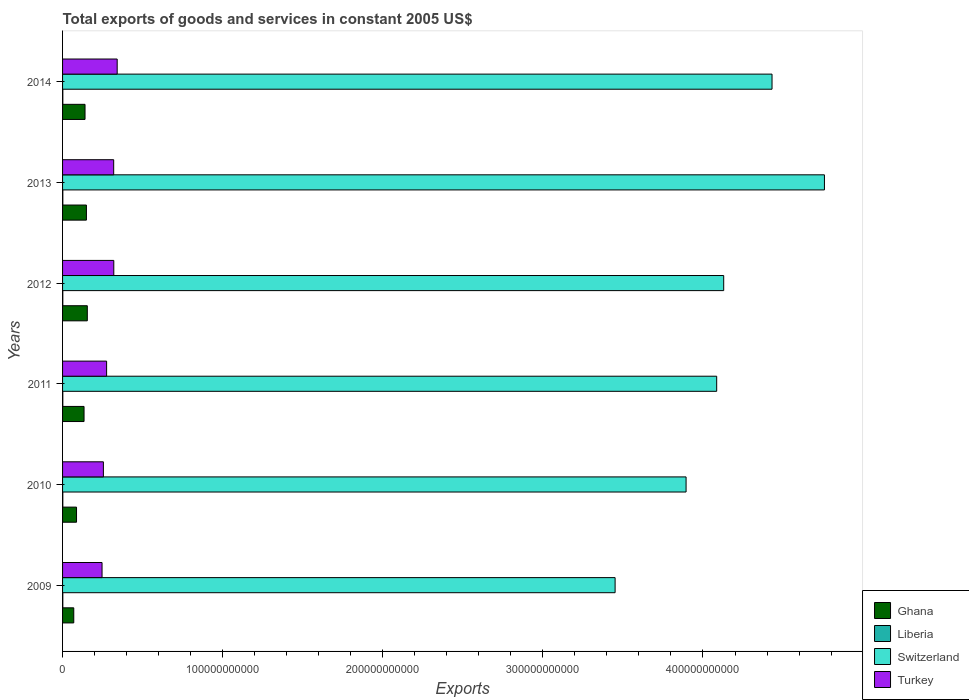How many different coloured bars are there?
Give a very brief answer. 4. Are the number of bars per tick equal to the number of legend labels?
Make the answer very short. Yes. Are the number of bars on each tick of the Y-axis equal?
Offer a very short reply. Yes. How many bars are there on the 4th tick from the top?
Your response must be concise. 4. In how many cases, is the number of bars for a given year not equal to the number of legend labels?
Make the answer very short. 0. What is the total exports of goods and services in Liberia in 2009?
Your answer should be compact. 1.51e+08. Across all years, what is the maximum total exports of goods and services in Turkey?
Make the answer very short. 3.41e+1. Across all years, what is the minimum total exports of goods and services in Ghana?
Your response must be concise. 7.00e+09. What is the total total exports of goods and services in Liberia in the graph?
Keep it short and to the point. 9.38e+08. What is the difference between the total exports of goods and services in Ghana in 2009 and that in 2014?
Your response must be concise. -7.03e+09. What is the difference between the total exports of goods and services in Liberia in 2011 and the total exports of goods and services in Switzerland in 2013?
Make the answer very short. -4.76e+11. What is the average total exports of goods and services in Switzerland per year?
Your answer should be very brief. 4.13e+11. In the year 2009, what is the difference between the total exports of goods and services in Turkey and total exports of goods and services in Ghana?
Offer a terse response. 1.77e+1. What is the ratio of the total exports of goods and services in Ghana in 2010 to that in 2012?
Offer a very short reply. 0.56. What is the difference between the highest and the second highest total exports of goods and services in Turkey?
Offer a terse response. 2.11e+09. What is the difference between the highest and the lowest total exports of goods and services in Switzerland?
Offer a terse response. 1.31e+11. Is the sum of the total exports of goods and services in Ghana in 2009 and 2010 greater than the maximum total exports of goods and services in Switzerland across all years?
Offer a very short reply. No. Is it the case that in every year, the sum of the total exports of goods and services in Switzerland and total exports of goods and services in Liberia is greater than the sum of total exports of goods and services in Turkey and total exports of goods and services in Ghana?
Offer a very short reply. Yes. Are all the bars in the graph horizontal?
Offer a terse response. Yes. What is the difference between two consecutive major ticks on the X-axis?
Your answer should be compact. 1.00e+11. Are the values on the major ticks of X-axis written in scientific E-notation?
Your answer should be very brief. No. Does the graph contain any zero values?
Ensure brevity in your answer.  No. Does the graph contain grids?
Offer a terse response. No. How many legend labels are there?
Offer a terse response. 4. What is the title of the graph?
Provide a short and direct response. Total exports of goods and services in constant 2005 US$. What is the label or title of the X-axis?
Make the answer very short. Exports. What is the label or title of the Y-axis?
Provide a short and direct response. Years. What is the Exports in Ghana in 2009?
Ensure brevity in your answer.  7.00e+09. What is the Exports in Liberia in 2009?
Ensure brevity in your answer.  1.51e+08. What is the Exports in Switzerland in 2009?
Offer a terse response. 3.45e+11. What is the Exports of Turkey in 2009?
Keep it short and to the point. 2.47e+1. What is the Exports in Ghana in 2010?
Offer a very short reply. 8.72e+09. What is the Exports in Liberia in 2010?
Ensure brevity in your answer.  1.53e+08. What is the Exports in Switzerland in 2010?
Offer a very short reply. 3.89e+11. What is the Exports of Turkey in 2010?
Provide a short and direct response. 2.55e+1. What is the Exports of Ghana in 2011?
Your response must be concise. 1.34e+1. What is the Exports of Liberia in 2011?
Give a very brief answer. 1.55e+08. What is the Exports of Switzerland in 2011?
Keep it short and to the point. 4.09e+11. What is the Exports in Turkey in 2011?
Ensure brevity in your answer.  2.75e+1. What is the Exports in Ghana in 2012?
Ensure brevity in your answer.  1.55e+1. What is the Exports of Liberia in 2012?
Your answer should be compact. 1.57e+08. What is the Exports in Switzerland in 2012?
Offer a very short reply. 4.13e+11. What is the Exports of Turkey in 2012?
Provide a short and direct response. 3.20e+1. What is the Exports of Ghana in 2013?
Your answer should be compact. 1.49e+1. What is the Exports of Liberia in 2013?
Make the answer very short. 1.60e+08. What is the Exports in Switzerland in 2013?
Offer a very short reply. 4.76e+11. What is the Exports of Turkey in 2013?
Your response must be concise. 3.19e+1. What is the Exports of Ghana in 2014?
Keep it short and to the point. 1.40e+1. What is the Exports of Liberia in 2014?
Ensure brevity in your answer.  1.62e+08. What is the Exports in Switzerland in 2014?
Your answer should be very brief. 4.43e+11. What is the Exports of Turkey in 2014?
Provide a short and direct response. 3.41e+1. Across all years, what is the maximum Exports of Ghana?
Your response must be concise. 1.55e+1. Across all years, what is the maximum Exports of Liberia?
Offer a terse response. 1.62e+08. Across all years, what is the maximum Exports in Switzerland?
Your answer should be compact. 4.76e+11. Across all years, what is the maximum Exports in Turkey?
Provide a succinct answer. 3.41e+1. Across all years, what is the minimum Exports of Ghana?
Provide a short and direct response. 7.00e+09. Across all years, what is the minimum Exports in Liberia?
Your answer should be very brief. 1.51e+08. Across all years, what is the minimum Exports in Switzerland?
Offer a terse response. 3.45e+11. Across all years, what is the minimum Exports of Turkey?
Provide a succinct answer. 2.47e+1. What is the total Exports of Ghana in the graph?
Your answer should be compact. 7.35e+1. What is the total Exports of Liberia in the graph?
Offer a terse response. 9.38e+08. What is the total Exports in Switzerland in the graph?
Ensure brevity in your answer.  2.48e+12. What is the total Exports of Turkey in the graph?
Offer a terse response. 1.76e+11. What is the difference between the Exports of Ghana in 2009 and that in 2010?
Give a very brief answer. -1.73e+09. What is the difference between the Exports in Liberia in 2009 and that in 2010?
Provide a short and direct response. -2.00e+06. What is the difference between the Exports in Switzerland in 2009 and that in 2010?
Ensure brevity in your answer.  -4.43e+1. What is the difference between the Exports of Turkey in 2009 and that in 2010?
Keep it short and to the point. -8.40e+08. What is the difference between the Exports of Ghana in 2009 and that in 2011?
Give a very brief answer. -6.42e+09. What is the difference between the Exports in Liberia in 2009 and that in 2011?
Your response must be concise. -4.09e+06. What is the difference between the Exports of Switzerland in 2009 and that in 2011?
Your response must be concise. -6.34e+1. What is the difference between the Exports of Turkey in 2009 and that in 2011?
Ensure brevity in your answer.  -2.85e+09. What is the difference between the Exports of Ghana in 2009 and that in 2012?
Offer a very short reply. -8.46e+09. What is the difference between the Exports of Liberia in 2009 and that in 2012?
Offer a very short reply. -6.21e+06. What is the difference between the Exports in Switzerland in 2009 and that in 2012?
Offer a terse response. -6.78e+1. What is the difference between the Exports in Turkey in 2009 and that in 2012?
Make the answer very short. -7.34e+09. What is the difference between the Exports of Ghana in 2009 and that in 2013?
Give a very brief answer. -7.90e+09. What is the difference between the Exports of Liberia in 2009 and that in 2013?
Your answer should be compact. -8.36e+06. What is the difference between the Exports of Switzerland in 2009 and that in 2013?
Your answer should be compact. -1.31e+11. What is the difference between the Exports in Turkey in 2009 and that in 2013?
Keep it short and to the point. -7.27e+09. What is the difference between the Exports in Ghana in 2009 and that in 2014?
Your response must be concise. -7.03e+09. What is the difference between the Exports of Liberia in 2009 and that in 2014?
Provide a succinct answer. -1.05e+07. What is the difference between the Exports in Switzerland in 2009 and that in 2014?
Your answer should be compact. -9.80e+1. What is the difference between the Exports in Turkey in 2009 and that in 2014?
Ensure brevity in your answer.  -9.45e+09. What is the difference between the Exports of Ghana in 2010 and that in 2011?
Make the answer very short. -4.70e+09. What is the difference between the Exports in Liberia in 2010 and that in 2011?
Provide a short and direct response. -2.09e+06. What is the difference between the Exports of Switzerland in 2010 and that in 2011?
Your answer should be very brief. -1.91e+1. What is the difference between the Exports in Turkey in 2010 and that in 2011?
Your answer should be compact. -2.01e+09. What is the difference between the Exports of Ghana in 2010 and that in 2012?
Your answer should be very brief. -6.73e+09. What is the difference between the Exports in Liberia in 2010 and that in 2012?
Ensure brevity in your answer.  -4.21e+06. What is the difference between the Exports in Switzerland in 2010 and that in 2012?
Offer a very short reply. -2.35e+1. What is the difference between the Exports in Turkey in 2010 and that in 2012?
Your answer should be very brief. -6.50e+09. What is the difference between the Exports of Ghana in 2010 and that in 2013?
Offer a terse response. -6.18e+09. What is the difference between the Exports in Liberia in 2010 and that in 2013?
Offer a terse response. -6.36e+06. What is the difference between the Exports in Switzerland in 2010 and that in 2013?
Ensure brevity in your answer.  -8.64e+1. What is the difference between the Exports of Turkey in 2010 and that in 2013?
Give a very brief answer. -6.43e+09. What is the difference between the Exports of Ghana in 2010 and that in 2014?
Your answer should be very brief. -5.31e+09. What is the difference between the Exports in Liberia in 2010 and that in 2014?
Make the answer very short. -8.54e+06. What is the difference between the Exports of Switzerland in 2010 and that in 2014?
Give a very brief answer. -5.37e+1. What is the difference between the Exports in Turkey in 2010 and that in 2014?
Offer a very short reply. -8.61e+09. What is the difference between the Exports of Ghana in 2011 and that in 2012?
Offer a very short reply. -2.04e+09. What is the difference between the Exports of Liberia in 2011 and that in 2012?
Provide a short and direct response. -2.12e+06. What is the difference between the Exports in Switzerland in 2011 and that in 2012?
Your answer should be very brief. -4.38e+09. What is the difference between the Exports in Turkey in 2011 and that in 2012?
Your response must be concise. -4.49e+09. What is the difference between the Exports in Ghana in 2011 and that in 2013?
Make the answer very short. -1.48e+09. What is the difference between the Exports of Liberia in 2011 and that in 2013?
Make the answer very short. -4.27e+06. What is the difference between the Exports of Switzerland in 2011 and that in 2013?
Provide a succinct answer. -6.73e+1. What is the difference between the Exports in Turkey in 2011 and that in 2013?
Offer a terse response. -4.42e+09. What is the difference between the Exports of Ghana in 2011 and that in 2014?
Your answer should be compact. -6.12e+08. What is the difference between the Exports in Liberia in 2011 and that in 2014?
Keep it short and to the point. -6.45e+06. What is the difference between the Exports of Switzerland in 2011 and that in 2014?
Offer a very short reply. -3.46e+1. What is the difference between the Exports in Turkey in 2011 and that in 2014?
Ensure brevity in your answer.  -6.60e+09. What is the difference between the Exports in Ghana in 2012 and that in 2013?
Provide a short and direct response. 5.57e+08. What is the difference between the Exports of Liberia in 2012 and that in 2013?
Your answer should be very brief. -2.15e+06. What is the difference between the Exports in Switzerland in 2012 and that in 2013?
Your response must be concise. -6.29e+1. What is the difference between the Exports in Turkey in 2012 and that in 2013?
Give a very brief answer. 6.73e+07. What is the difference between the Exports of Ghana in 2012 and that in 2014?
Make the answer very short. 1.43e+09. What is the difference between the Exports in Liberia in 2012 and that in 2014?
Give a very brief answer. -4.33e+06. What is the difference between the Exports in Switzerland in 2012 and that in 2014?
Provide a succinct answer. -3.02e+1. What is the difference between the Exports in Turkey in 2012 and that in 2014?
Offer a terse response. -2.11e+09. What is the difference between the Exports in Ghana in 2013 and that in 2014?
Give a very brief answer. 8.69e+08. What is the difference between the Exports of Liberia in 2013 and that in 2014?
Keep it short and to the point. -2.18e+06. What is the difference between the Exports of Switzerland in 2013 and that in 2014?
Provide a short and direct response. 3.27e+1. What is the difference between the Exports in Turkey in 2013 and that in 2014?
Your response must be concise. -2.18e+09. What is the difference between the Exports in Ghana in 2009 and the Exports in Liberia in 2010?
Provide a short and direct response. 6.84e+09. What is the difference between the Exports of Ghana in 2009 and the Exports of Switzerland in 2010?
Offer a terse response. -3.82e+11. What is the difference between the Exports in Ghana in 2009 and the Exports in Turkey in 2010?
Your response must be concise. -1.85e+1. What is the difference between the Exports in Liberia in 2009 and the Exports in Switzerland in 2010?
Give a very brief answer. -3.89e+11. What is the difference between the Exports in Liberia in 2009 and the Exports in Turkey in 2010?
Your answer should be very brief. -2.53e+1. What is the difference between the Exports of Switzerland in 2009 and the Exports of Turkey in 2010?
Keep it short and to the point. 3.20e+11. What is the difference between the Exports in Ghana in 2009 and the Exports in Liberia in 2011?
Provide a succinct answer. 6.84e+09. What is the difference between the Exports in Ghana in 2009 and the Exports in Switzerland in 2011?
Provide a short and direct response. -4.02e+11. What is the difference between the Exports of Ghana in 2009 and the Exports of Turkey in 2011?
Your response must be concise. -2.05e+1. What is the difference between the Exports of Liberia in 2009 and the Exports of Switzerland in 2011?
Your response must be concise. -4.08e+11. What is the difference between the Exports in Liberia in 2009 and the Exports in Turkey in 2011?
Your answer should be compact. -2.74e+1. What is the difference between the Exports of Switzerland in 2009 and the Exports of Turkey in 2011?
Provide a short and direct response. 3.18e+11. What is the difference between the Exports in Ghana in 2009 and the Exports in Liberia in 2012?
Your answer should be compact. 6.84e+09. What is the difference between the Exports in Ghana in 2009 and the Exports in Switzerland in 2012?
Keep it short and to the point. -4.06e+11. What is the difference between the Exports of Ghana in 2009 and the Exports of Turkey in 2012?
Give a very brief answer. -2.50e+1. What is the difference between the Exports in Liberia in 2009 and the Exports in Switzerland in 2012?
Your answer should be very brief. -4.13e+11. What is the difference between the Exports of Liberia in 2009 and the Exports of Turkey in 2012?
Keep it short and to the point. -3.18e+1. What is the difference between the Exports of Switzerland in 2009 and the Exports of Turkey in 2012?
Offer a terse response. 3.13e+11. What is the difference between the Exports in Ghana in 2009 and the Exports in Liberia in 2013?
Keep it short and to the point. 6.84e+09. What is the difference between the Exports of Ghana in 2009 and the Exports of Switzerland in 2013?
Keep it short and to the point. -4.69e+11. What is the difference between the Exports of Ghana in 2009 and the Exports of Turkey in 2013?
Offer a very short reply. -2.49e+1. What is the difference between the Exports in Liberia in 2009 and the Exports in Switzerland in 2013?
Your response must be concise. -4.76e+11. What is the difference between the Exports of Liberia in 2009 and the Exports of Turkey in 2013?
Your response must be concise. -3.18e+1. What is the difference between the Exports of Switzerland in 2009 and the Exports of Turkey in 2013?
Offer a very short reply. 3.13e+11. What is the difference between the Exports in Ghana in 2009 and the Exports in Liberia in 2014?
Ensure brevity in your answer.  6.83e+09. What is the difference between the Exports in Ghana in 2009 and the Exports in Switzerland in 2014?
Make the answer very short. -4.36e+11. What is the difference between the Exports in Ghana in 2009 and the Exports in Turkey in 2014?
Give a very brief answer. -2.71e+1. What is the difference between the Exports in Liberia in 2009 and the Exports in Switzerland in 2014?
Offer a very short reply. -4.43e+11. What is the difference between the Exports in Liberia in 2009 and the Exports in Turkey in 2014?
Offer a very short reply. -3.40e+1. What is the difference between the Exports in Switzerland in 2009 and the Exports in Turkey in 2014?
Offer a terse response. 3.11e+11. What is the difference between the Exports of Ghana in 2010 and the Exports of Liberia in 2011?
Keep it short and to the point. 8.57e+09. What is the difference between the Exports of Ghana in 2010 and the Exports of Switzerland in 2011?
Provide a short and direct response. -4.00e+11. What is the difference between the Exports of Ghana in 2010 and the Exports of Turkey in 2011?
Keep it short and to the point. -1.88e+1. What is the difference between the Exports of Liberia in 2010 and the Exports of Switzerland in 2011?
Your answer should be compact. -4.08e+11. What is the difference between the Exports in Liberia in 2010 and the Exports in Turkey in 2011?
Keep it short and to the point. -2.74e+1. What is the difference between the Exports of Switzerland in 2010 and the Exports of Turkey in 2011?
Keep it short and to the point. 3.62e+11. What is the difference between the Exports of Ghana in 2010 and the Exports of Liberia in 2012?
Provide a succinct answer. 8.57e+09. What is the difference between the Exports of Ghana in 2010 and the Exports of Switzerland in 2012?
Provide a short and direct response. -4.04e+11. What is the difference between the Exports in Ghana in 2010 and the Exports in Turkey in 2012?
Make the answer very short. -2.33e+1. What is the difference between the Exports in Liberia in 2010 and the Exports in Switzerland in 2012?
Your answer should be very brief. -4.13e+11. What is the difference between the Exports in Liberia in 2010 and the Exports in Turkey in 2012?
Your response must be concise. -3.18e+1. What is the difference between the Exports of Switzerland in 2010 and the Exports of Turkey in 2012?
Give a very brief answer. 3.57e+11. What is the difference between the Exports in Ghana in 2010 and the Exports in Liberia in 2013?
Give a very brief answer. 8.56e+09. What is the difference between the Exports of Ghana in 2010 and the Exports of Switzerland in 2013?
Offer a very short reply. -4.67e+11. What is the difference between the Exports of Ghana in 2010 and the Exports of Turkey in 2013?
Provide a succinct answer. -2.32e+1. What is the difference between the Exports in Liberia in 2010 and the Exports in Switzerland in 2013?
Your response must be concise. -4.76e+11. What is the difference between the Exports of Liberia in 2010 and the Exports of Turkey in 2013?
Offer a terse response. -3.18e+1. What is the difference between the Exports of Switzerland in 2010 and the Exports of Turkey in 2013?
Provide a short and direct response. 3.58e+11. What is the difference between the Exports of Ghana in 2010 and the Exports of Liberia in 2014?
Offer a terse response. 8.56e+09. What is the difference between the Exports in Ghana in 2010 and the Exports in Switzerland in 2014?
Your answer should be compact. -4.34e+11. What is the difference between the Exports in Ghana in 2010 and the Exports in Turkey in 2014?
Your response must be concise. -2.54e+1. What is the difference between the Exports in Liberia in 2010 and the Exports in Switzerland in 2014?
Make the answer very short. -4.43e+11. What is the difference between the Exports in Liberia in 2010 and the Exports in Turkey in 2014?
Keep it short and to the point. -3.40e+1. What is the difference between the Exports in Switzerland in 2010 and the Exports in Turkey in 2014?
Your response must be concise. 3.55e+11. What is the difference between the Exports in Ghana in 2011 and the Exports in Liberia in 2012?
Make the answer very short. 1.33e+1. What is the difference between the Exports in Ghana in 2011 and the Exports in Switzerland in 2012?
Provide a succinct answer. -4.00e+11. What is the difference between the Exports in Ghana in 2011 and the Exports in Turkey in 2012?
Offer a terse response. -1.86e+1. What is the difference between the Exports of Liberia in 2011 and the Exports of Switzerland in 2012?
Keep it short and to the point. -4.13e+11. What is the difference between the Exports in Liberia in 2011 and the Exports in Turkey in 2012?
Your answer should be very brief. -3.18e+1. What is the difference between the Exports in Switzerland in 2011 and the Exports in Turkey in 2012?
Your response must be concise. 3.77e+11. What is the difference between the Exports of Ghana in 2011 and the Exports of Liberia in 2013?
Your answer should be compact. 1.33e+1. What is the difference between the Exports in Ghana in 2011 and the Exports in Switzerland in 2013?
Your answer should be compact. -4.62e+11. What is the difference between the Exports of Ghana in 2011 and the Exports of Turkey in 2013?
Your answer should be very brief. -1.85e+1. What is the difference between the Exports in Liberia in 2011 and the Exports in Switzerland in 2013?
Provide a short and direct response. -4.76e+11. What is the difference between the Exports in Liberia in 2011 and the Exports in Turkey in 2013?
Keep it short and to the point. -3.18e+1. What is the difference between the Exports in Switzerland in 2011 and the Exports in Turkey in 2013?
Provide a succinct answer. 3.77e+11. What is the difference between the Exports of Ghana in 2011 and the Exports of Liberia in 2014?
Ensure brevity in your answer.  1.33e+1. What is the difference between the Exports in Ghana in 2011 and the Exports in Switzerland in 2014?
Provide a short and direct response. -4.30e+11. What is the difference between the Exports in Ghana in 2011 and the Exports in Turkey in 2014?
Your answer should be compact. -2.07e+1. What is the difference between the Exports of Liberia in 2011 and the Exports of Switzerland in 2014?
Provide a short and direct response. -4.43e+11. What is the difference between the Exports in Liberia in 2011 and the Exports in Turkey in 2014?
Offer a terse response. -3.40e+1. What is the difference between the Exports of Switzerland in 2011 and the Exports of Turkey in 2014?
Your response must be concise. 3.74e+11. What is the difference between the Exports of Ghana in 2012 and the Exports of Liberia in 2013?
Your answer should be very brief. 1.53e+1. What is the difference between the Exports in Ghana in 2012 and the Exports in Switzerland in 2013?
Ensure brevity in your answer.  -4.60e+11. What is the difference between the Exports in Ghana in 2012 and the Exports in Turkey in 2013?
Make the answer very short. -1.65e+1. What is the difference between the Exports of Liberia in 2012 and the Exports of Switzerland in 2013?
Your answer should be compact. -4.76e+11. What is the difference between the Exports in Liberia in 2012 and the Exports in Turkey in 2013?
Give a very brief answer. -3.18e+1. What is the difference between the Exports in Switzerland in 2012 and the Exports in Turkey in 2013?
Ensure brevity in your answer.  3.81e+11. What is the difference between the Exports of Ghana in 2012 and the Exports of Liberia in 2014?
Give a very brief answer. 1.53e+1. What is the difference between the Exports in Ghana in 2012 and the Exports in Switzerland in 2014?
Keep it short and to the point. -4.28e+11. What is the difference between the Exports of Ghana in 2012 and the Exports of Turkey in 2014?
Keep it short and to the point. -1.87e+1. What is the difference between the Exports of Liberia in 2012 and the Exports of Switzerland in 2014?
Provide a short and direct response. -4.43e+11. What is the difference between the Exports in Liberia in 2012 and the Exports in Turkey in 2014?
Your response must be concise. -3.40e+1. What is the difference between the Exports in Switzerland in 2012 and the Exports in Turkey in 2014?
Make the answer very short. 3.79e+11. What is the difference between the Exports in Ghana in 2013 and the Exports in Liberia in 2014?
Your answer should be compact. 1.47e+1. What is the difference between the Exports of Ghana in 2013 and the Exports of Switzerland in 2014?
Your response must be concise. -4.28e+11. What is the difference between the Exports in Ghana in 2013 and the Exports in Turkey in 2014?
Offer a very short reply. -1.92e+1. What is the difference between the Exports in Liberia in 2013 and the Exports in Switzerland in 2014?
Provide a short and direct response. -4.43e+11. What is the difference between the Exports of Liberia in 2013 and the Exports of Turkey in 2014?
Ensure brevity in your answer.  -3.40e+1. What is the difference between the Exports in Switzerland in 2013 and the Exports in Turkey in 2014?
Provide a succinct answer. 4.42e+11. What is the average Exports of Ghana per year?
Your response must be concise. 1.23e+1. What is the average Exports of Liberia per year?
Provide a short and direct response. 1.56e+08. What is the average Exports in Switzerland per year?
Your answer should be compact. 4.13e+11. What is the average Exports of Turkey per year?
Provide a succinct answer. 2.93e+1. In the year 2009, what is the difference between the Exports in Ghana and Exports in Liberia?
Offer a very short reply. 6.84e+09. In the year 2009, what is the difference between the Exports of Ghana and Exports of Switzerland?
Give a very brief answer. -3.38e+11. In the year 2009, what is the difference between the Exports in Ghana and Exports in Turkey?
Keep it short and to the point. -1.77e+1. In the year 2009, what is the difference between the Exports in Liberia and Exports in Switzerland?
Make the answer very short. -3.45e+11. In the year 2009, what is the difference between the Exports in Liberia and Exports in Turkey?
Your answer should be very brief. -2.45e+1. In the year 2009, what is the difference between the Exports in Switzerland and Exports in Turkey?
Your response must be concise. 3.20e+11. In the year 2010, what is the difference between the Exports in Ghana and Exports in Liberia?
Your answer should be very brief. 8.57e+09. In the year 2010, what is the difference between the Exports in Ghana and Exports in Switzerland?
Provide a short and direct response. -3.81e+11. In the year 2010, what is the difference between the Exports of Ghana and Exports of Turkey?
Give a very brief answer. -1.68e+1. In the year 2010, what is the difference between the Exports in Liberia and Exports in Switzerland?
Keep it short and to the point. -3.89e+11. In the year 2010, what is the difference between the Exports in Liberia and Exports in Turkey?
Your answer should be compact. -2.53e+1. In the year 2010, what is the difference between the Exports of Switzerland and Exports of Turkey?
Your answer should be compact. 3.64e+11. In the year 2011, what is the difference between the Exports in Ghana and Exports in Liberia?
Keep it short and to the point. 1.33e+1. In the year 2011, what is the difference between the Exports of Ghana and Exports of Switzerland?
Offer a very short reply. -3.95e+11. In the year 2011, what is the difference between the Exports of Ghana and Exports of Turkey?
Your response must be concise. -1.41e+1. In the year 2011, what is the difference between the Exports of Liberia and Exports of Switzerland?
Make the answer very short. -4.08e+11. In the year 2011, what is the difference between the Exports in Liberia and Exports in Turkey?
Your answer should be compact. -2.74e+1. In the year 2011, what is the difference between the Exports of Switzerland and Exports of Turkey?
Make the answer very short. 3.81e+11. In the year 2012, what is the difference between the Exports of Ghana and Exports of Liberia?
Provide a succinct answer. 1.53e+1. In the year 2012, what is the difference between the Exports of Ghana and Exports of Switzerland?
Your answer should be compact. -3.97e+11. In the year 2012, what is the difference between the Exports of Ghana and Exports of Turkey?
Provide a short and direct response. -1.65e+1. In the year 2012, what is the difference between the Exports of Liberia and Exports of Switzerland?
Provide a short and direct response. -4.13e+11. In the year 2012, what is the difference between the Exports in Liberia and Exports in Turkey?
Your response must be concise. -3.18e+1. In the year 2012, what is the difference between the Exports in Switzerland and Exports in Turkey?
Offer a very short reply. 3.81e+11. In the year 2013, what is the difference between the Exports in Ghana and Exports in Liberia?
Offer a terse response. 1.47e+1. In the year 2013, what is the difference between the Exports of Ghana and Exports of Switzerland?
Keep it short and to the point. -4.61e+11. In the year 2013, what is the difference between the Exports in Ghana and Exports in Turkey?
Offer a terse response. -1.70e+1. In the year 2013, what is the difference between the Exports of Liberia and Exports of Switzerland?
Your answer should be compact. -4.76e+11. In the year 2013, what is the difference between the Exports of Liberia and Exports of Turkey?
Make the answer very short. -3.18e+1. In the year 2013, what is the difference between the Exports of Switzerland and Exports of Turkey?
Ensure brevity in your answer.  4.44e+11. In the year 2014, what is the difference between the Exports in Ghana and Exports in Liberia?
Ensure brevity in your answer.  1.39e+1. In the year 2014, what is the difference between the Exports of Ghana and Exports of Switzerland?
Give a very brief answer. -4.29e+11. In the year 2014, what is the difference between the Exports in Ghana and Exports in Turkey?
Give a very brief answer. -2.01e+1. In the year 2014, what is the difference between the Exports of Liberia and Exports of Switzerland?
Make the answer very short. -4.43e+11. In the year 2014, what is the difference between the Exports in Liberia and Exports in Turkey?
Ensure brevity in your answer.  -3.39e+1. In the year 2014, what is the difference between the Exports in Switzerland and Exports in Turkey?
Provide a succinct answer. 4.09e+11. What is the ratio of the Exports in Ghana in 2009 to that in 2010?
Provide a succinct answer. 0.8. What is the ratio of the Exports in Liberia in 2009 to that in 2010?
Give a very brief answer. 0.99. What is the ratio of the Exports in Switzerland in 2009 to that in 2010?
Your response must be concise. 0.89. What is the ratio of the Exports of Turkey in 2009 to that in 2010?
Make the answer very short. 0.97. What is the ratio of the Exports in Ghana in 2009 to that in 2011?
Provide a succinct answer. 0.52. What is the ratio of the Exports in Liberia in 2009 to that in 2011?
Offer a very short reply. 0.97. What is the ratio of the Exports in Switzerland in 2009 to that in 2011?
Your answer should be very brief. 0.84. What is the ratio of the Exports of Turkey in 2009 to that in 2011?
Your answer should be very brief. 0.9. What is the ratio of the Exports in Ghana in 2009 to that in 2012?
Make the answer very short. 0.45. What is the ratio of the Exports of Liberia in 2009 to that in 2012?
Offer a very short reply. 0.96. What is the ratio of the Exports in Switzerland in 2009 to that in 2012?
Provide a succinct answer. 0.84. What is the ratio of the Exports in Turkey in 2009 to that in 2012?
Your answer should be compact. 0.77. What is the ratio of the Exports in Ghana in 2009 to that in 2013?
Provide a succinct answer. 0.47. What is the ratio of the Exports in Liberia in 2009 to that in 2013?
Offer a very short reply. 0.95. What is the ratio of the Exports in Switzerland in 2009 to that in 2013?
Give a very brief answer. 0.73. What is the ratio of the Exports of Turkey in 2009 to that in 2013?
Provide a succinct answer. 0.77. What is the ratio of the Exports in Ghana in 2009 to that in 2014?
Ensure brevity in your answer.  0.5. What is the ratio of the Exports in Liberia in 2009 to that in 2014?
Provide a short and direct response. 0.93. What is the ratio of the Exports in Switzerland in 2009 to that in 2014?
Your answer should be very brief. 0.78. What is the ratio of the Exports of Turkey in 2009 to that in 2014?
Your response must be concise. 0.72. What is the ratio of the Exports in Ghana in 2010 to that in 2011?
Your response must be concise. 0.65. What is the ratio of the Exports in Liberia in 2010 to that in 2011?
Your answer should be compact. 0.99. What is the ratio of the Exports in Switzerland in 2010 to that in 2011?
Give a very brief answer. 0.95. What is the ratio of the Exports in Turkey in 2010 to that in 2011?
Provide a short and direct response. 0.93. What is the ratio of the Exports in Ghana in 2010 to that in 2012?
Make the answer very short. 0.56. What is the ratio of the Exports in Liberia in 2010 to that in 2012?
Provide a succinct answer. 0.97. What is the ratio of the Exports in Switzerland in 2010 to that in 2012?
Provide a succinct answer. 0.94. What is the ratio of the Exports in Turkey in 2010 to that in 2012?
Give a very brief answer. 0.8. What is the ratio of the Exports in Ghana in 2010 to that in 2013?
Keep it short and to the point. 0.59. What is the ratio of the Exports in Liberia in 2010 to that in 2013?
Provide a short and direct response. 0.96. What is the ratio of the Exports in Switzerland in 2010 to that in 2013?
Keep it short and to the point. 0.82. What is the ratio of the Exports in Turkey in 2010 to that in 2013?
Offer a terse response. 0.8. What is the ratio of the Exports of Ghana in 2010 to that in 2014?
Give a very brief answer. 0.62. What is the ratio of the Exports in Liberia in 2010 to that in 2014?
Provide a succinct answer. 0.95. What is the ratio of the Exports of Switzerland in 2010 to that in 2014?
Your answer should be compact. 0.88. What is the ratio of the Exports in Turkey in 2010 to that in 2014?
Your answer should be compact. 0.75. What is the ratio of the Exports in Ghana in 2011 to that in 2012?
Your answer should be very brief. 0.87. What is the ratio of the Exports in Liberia in 2011 to that in 2012?
Keep it short and to the point. 0.99. What is the ratio of the Exports of Switzerland in 2011 to that in 2012?
Give a very brief answer. 0.99. What is the ratio of the Exports of Turkey in 2011 to that in 2012?
Ensure brevity in your answer.  0.86. What is the ratio of the Exports of Ghana in 2011 to that in 2013?
Your answer should be compact. 0.9. What is the ratio of the Exports in Liberia in 2011 to that in 2013?
Keep it short and to the point. 0.97. What is the ratio of the Exports in Switzerland in 2011 to that in 2013?
Keep it short and to the point. 0.86. What is the ratio of the Exports in Turkey in 2011 to that in 2013?
Keep it short and to the point. 0.86. What is the ratio of the Exports in Ghana in 2011 to that in 2014?
Your answer should be compact. 0.96. What is the ratio of the Exports in Liberia in 2011 to that in 2014?
Your answer should be compact. 0.96. What is the ratio of the Exports of Switzerland in 2011 to that in 2014?
Give a very brief answer. 0.92. What is the ratio of the Exports in Turkey in 2011 to that in 2014?
Make the answer very short. 0.81. What is the ratio of the Exports in Ghana in 2012 to that in 2013?
Ensure brevity in your answer.  1.04. What is the ratio of the Exports of Liberia in 2012 to that in 2013?
Your response must be concise. 0.99. What is the ratio of the Exports of Switzerland in 2012 to that in 2013?
Offer a terse response. 0.87. What is the ratio of the Exports of Ghana in 2012 to that in 2014?
Make the answer very short. 1.1. What is the ratio of the Exports of Liberia in 2012 to that in 2014?
Provide a short and direct response. 0.97. What is the ratio of the Exports in Switzerland in 2012 to that in 2014?
Give a very brief answer. 0.93. What is the ratio of the Exports in Turkey in 2012 to that in 2014?
Provide a succinct answer. 0.94. What is the ratio of the Exports of Ghana in 2013 to that in 2014?
Offer a terse response. 1.06. What is the ratio of the Exports of Liberia in 2013 to that in 2014?
Provide a succinct answer. 0.99. What is the ratio of the Exports in Switzerland in 2013 to that in 2014?
Offer a very short reply. 1.07. What is the ratio of the Exports in Turkey in 2013 to that in 2014?
Provide a short and direct response. 0.94. What is the difference between the highest and the second highest Exports of Ghana?
Offer a terse response. 5.57e+08. What is the difference between the highest and the second highest Exports in Liberia?
Offer a terse response. 2.18e+06. What is the difference between the highest and the second highest Exports of Switzerland?
Your answer should be compact. 3.27e+1. What is the difference between the highest and the second highest Exports in Turkey?
Your response must be concise. 2.11e+09. What is the difference between the highest and the lowest Exports of Ghana?
Provide a short and direct response. 8.46e+09. What is the difference between the highest and the lowest Exports of Liberia?
Provide a short and direct response. 1.05e+07. What is the difference between the highest and the lowest Exports in Switzerland?
Make the answer very short. 1.31e+11. What is the difference between the highest and the lowest Exports of Turkey?
Offer a very short reply. 9.45e+09. 